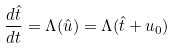<formula> <loc_0><loc_0><loc_500><loc_500>\frac { d \hat { t } } { d t } = \Lambda ( \hat { u } ) = \Lambda ( \hat { t } + u _ { 0 } )</formula> 